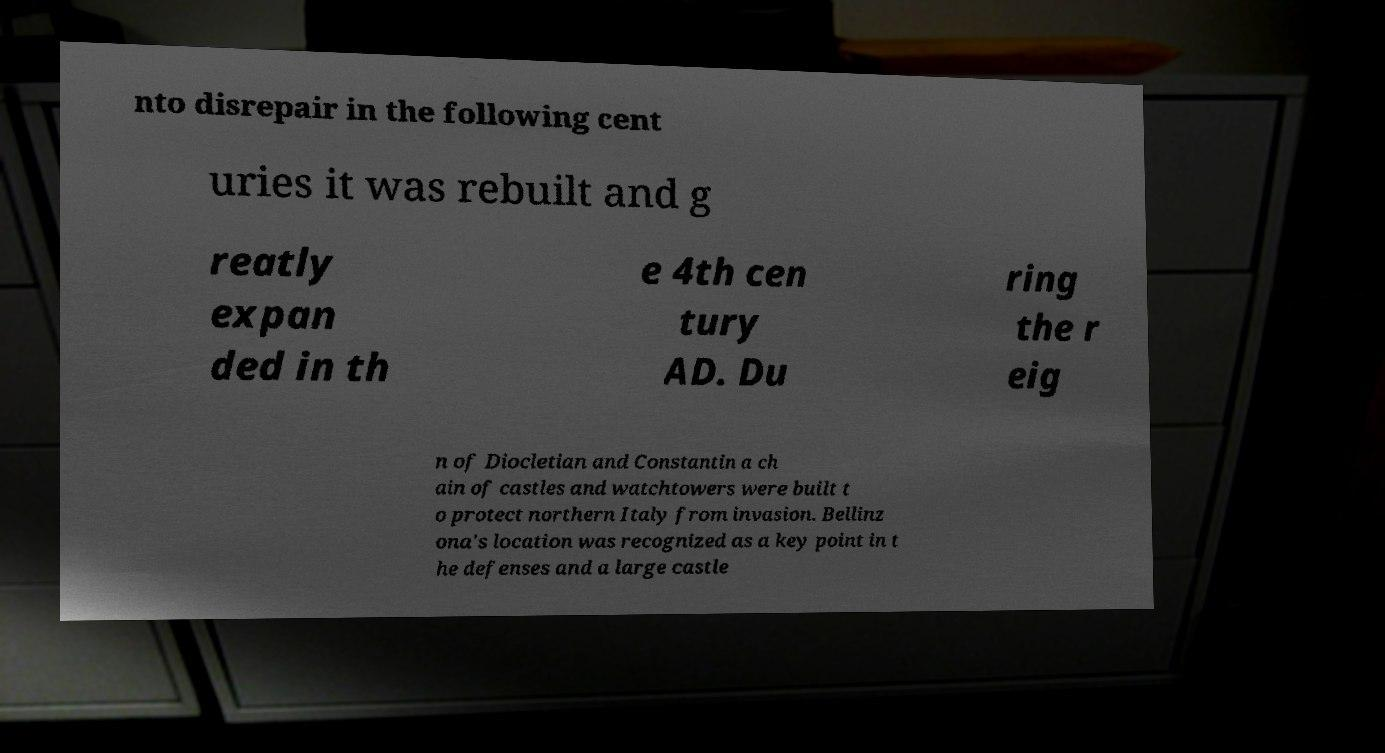Could you extract and type out the text from this image? nto disrepair in the following cent uries it was rebuilt and g reatly expan ded in th e 4th cen tury AD. Du ring the r eig n of Diocletian and Constantin a ch ain of castles and watchtowers were built t o protect northern Italy from invasion. Bellinz ona's location was recognized as a key point in t he defenses and a large castle 